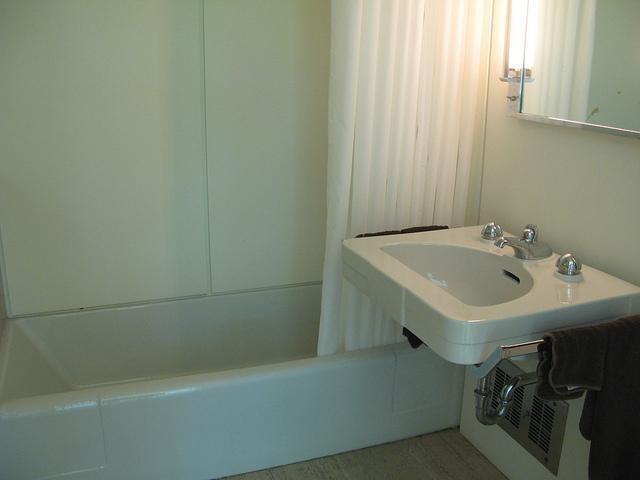How many sinks are here?
Give a very brief answer. 1. How many sinks are there?
Give a very brief answer. 1. 